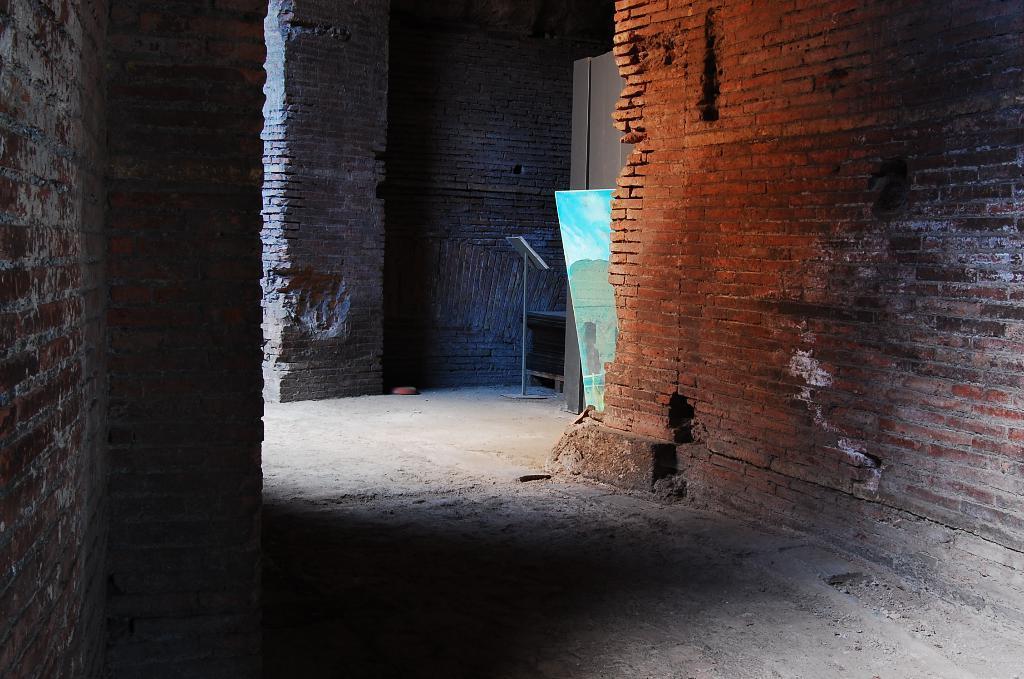Could you give a brief overview of what you see in this image? This image is clicked inside. There are stand and board in the middle. 